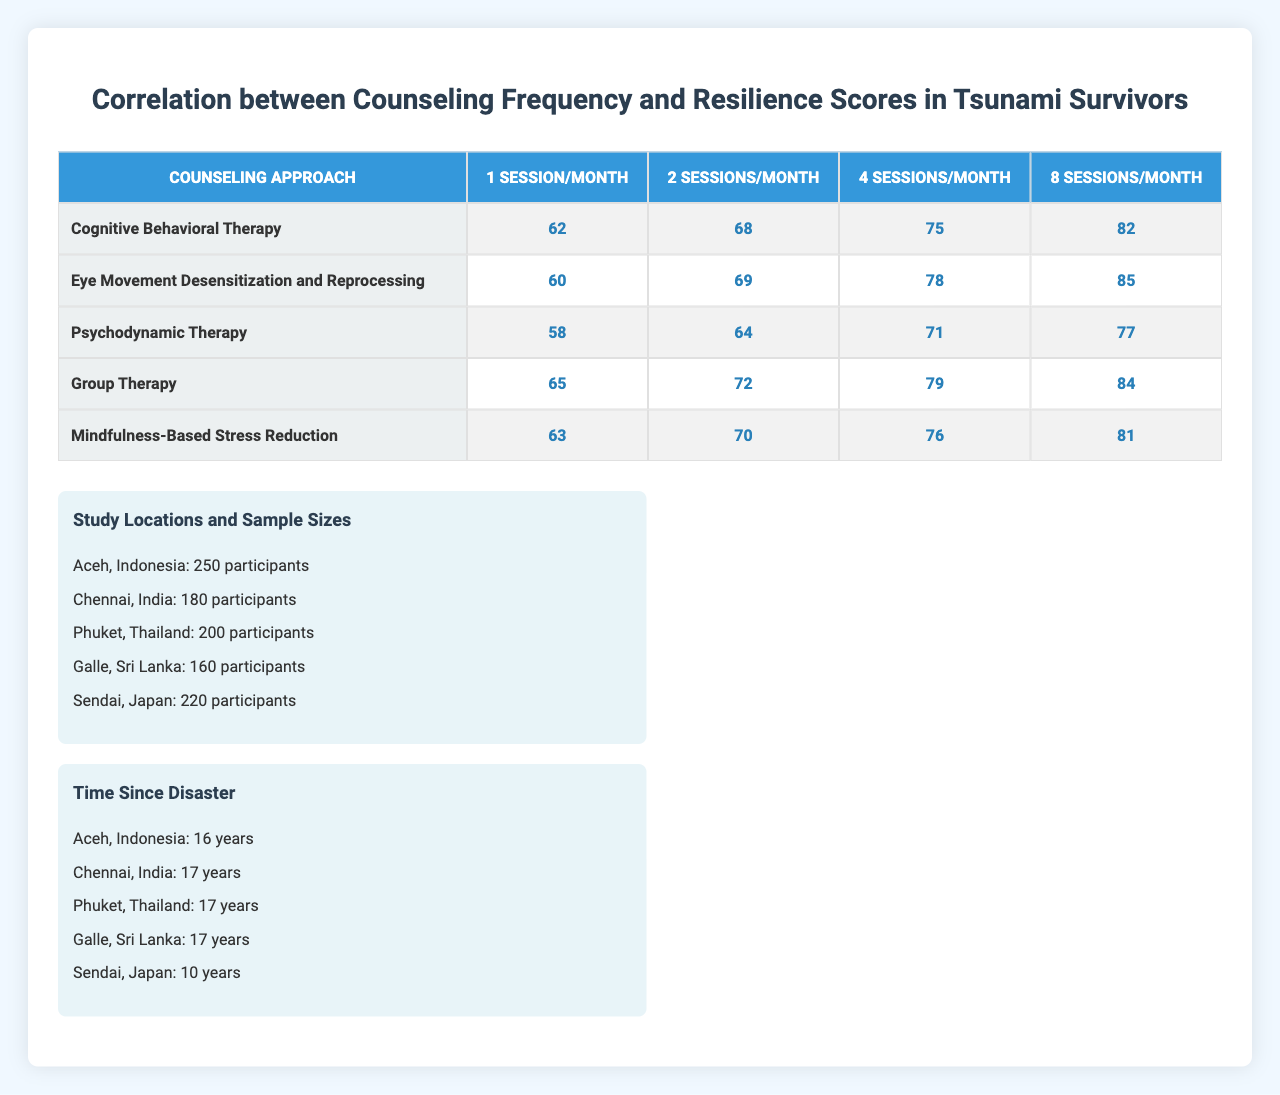What is the highest resilience score among the counseling approaches at 8 sessions per month? By examining the column for 8 sessions/month, the highest resilience score is 85, corresponding to the Eye Movement Desensitization and Reprocessing approach.
Answer: 85 Which counseling approach has the lowest resilience score at 1 session per month? The lowest value in the 1 session/month column is 58, which corresponds to Psychodynamic Therapy.
Answer: Psychodynamic Therapy What is the resilience score increase for Cognitive Behavioral Therapy from 1 to 8 sessions per month? The score for Cognitive Behavioral Therapy at 1 session/month is 62 and at 8 sessions/month is 82. The increase is 82 - 62 = 20.
Answer: 20 Which counseling approach consistently has higher resilience scores compared to others across all session frequencies? By comparing the rows, Group Therapy has the highest scores (65, 72, 79, 84) at all session frequencies compared to the other approaches.
Answer: Group Therapy What is the average resilience score for Eye Movement Desensitization and Reprocessing across all the session frequencies? To find the average, sum the scores (60 + 69 + 78 + 85) = 292 and divide by the number of session frequencies (4), yielding an average of 292/4 = 73.
Answer: 73 True or False: The resilience scores for Psychodynamic Therapy at 4 sessions/month and Mindfulness-Based Stress Reduction at 2 sessions/month are the same. The score for Psychodynamic Therapy at 4 sessions/month is 71, while Mindfulness-Based Stress Reduction at 2 sessions/month is 70. Therefore, they are not the same.
Answer: False Which region has the largest sample size, and how many participants are there? Looking at the sample sizes, Aceh, Indonesia has the largest size with 250 participants.
Answer: 250 participants What is the difference in resilience scores between Group Therapy and Mindfulness-Based Stress Reduction at 4 sessions per month? At 4 sessions/month, Group Therapy has a score of 79 and Mindfulness-Based Stress Reduction has a score of 76. Thus, the difference is 79 - 76 = 3.
Answer: 3 What resilience score pattern can be seen across all counseling approaches as the frequency of sessions increases? As the session frequency increases from 1 to 8 per month, resilience scores generally increase across all counseling approaches, indicating a positive correlation between session frequency and resilience.
Answer: Scores increase Which study location has the least time since disaster, and what is that duration? The least time since disaster is recorded in Sendai, Japan, which is 10 years.
Answer: 10 years What is the overall trend in resilience scores as counseling frequency increases across all approaches? The overall trend shows that resilience scores increase with more frequent counseling sessions, indicating the effectiveness of higher frequencies of counseling.
Answer: Increasing trend 